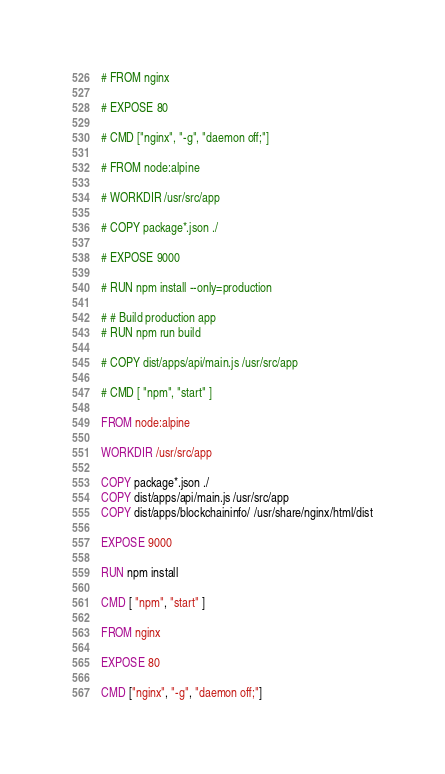<code> <loc_0><loc_0><loc_500><loc_500><_Dockerfile_># FROM nginx

# EXPOSE 80

# CMD ["nginx", "-g", "daemon off;"]

# FROM node:alpine

# WORKDIR /usr/src/app

# COPY package*.json ./

# EXPOSE 9000

# RUN npm install --only=production

# # Build production app
# RUN npm run build

# COPY dist/apps/api/main.js /usr/src/app

# CMD [ "npm", "start" ]

FROM node:alpine

WORKDIR /usr/src/app

COPY package*.json ./
COPY dist/apps/api/main.js /usr/src/app
COPY dist/apps/blockchaininfo/ /usr/share/nginx/html/dist

EXPOSE 9000

RUN npm install

CMD [ "npm", "start" ]

FROM nginx

EXPOSE 80

CMD ["nginx", "-g", "daemon off;"]</code> 